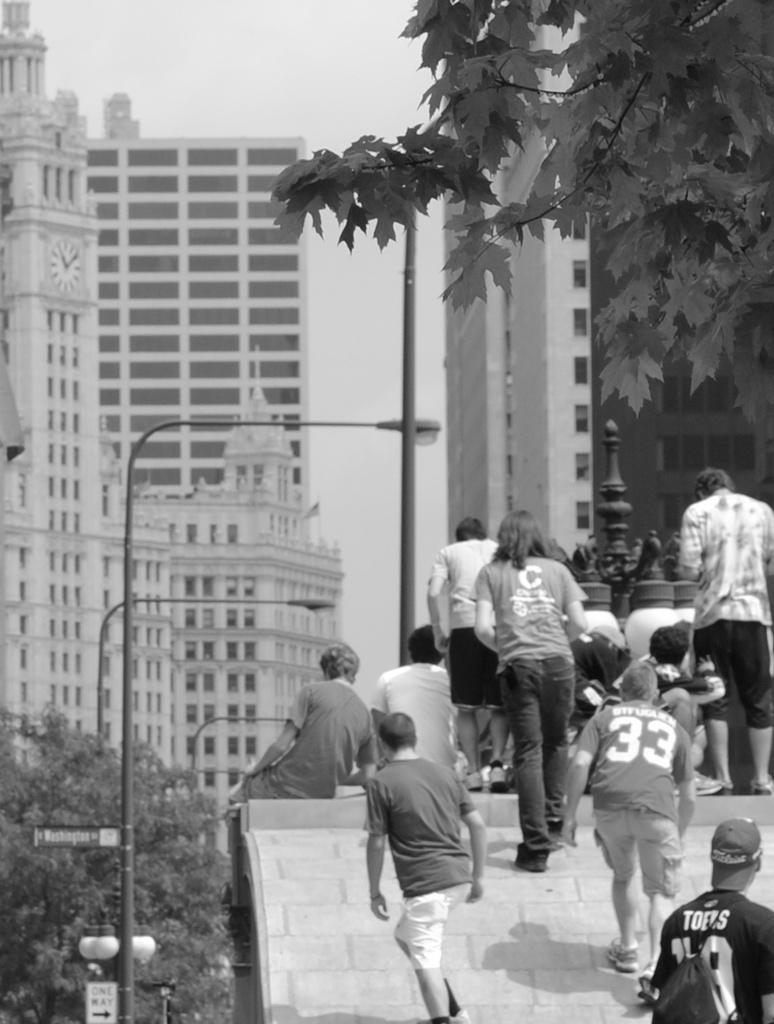Provide a one-sentence caption for the provided image. A kid with a 33 Jersey walking up a roof with other people. 